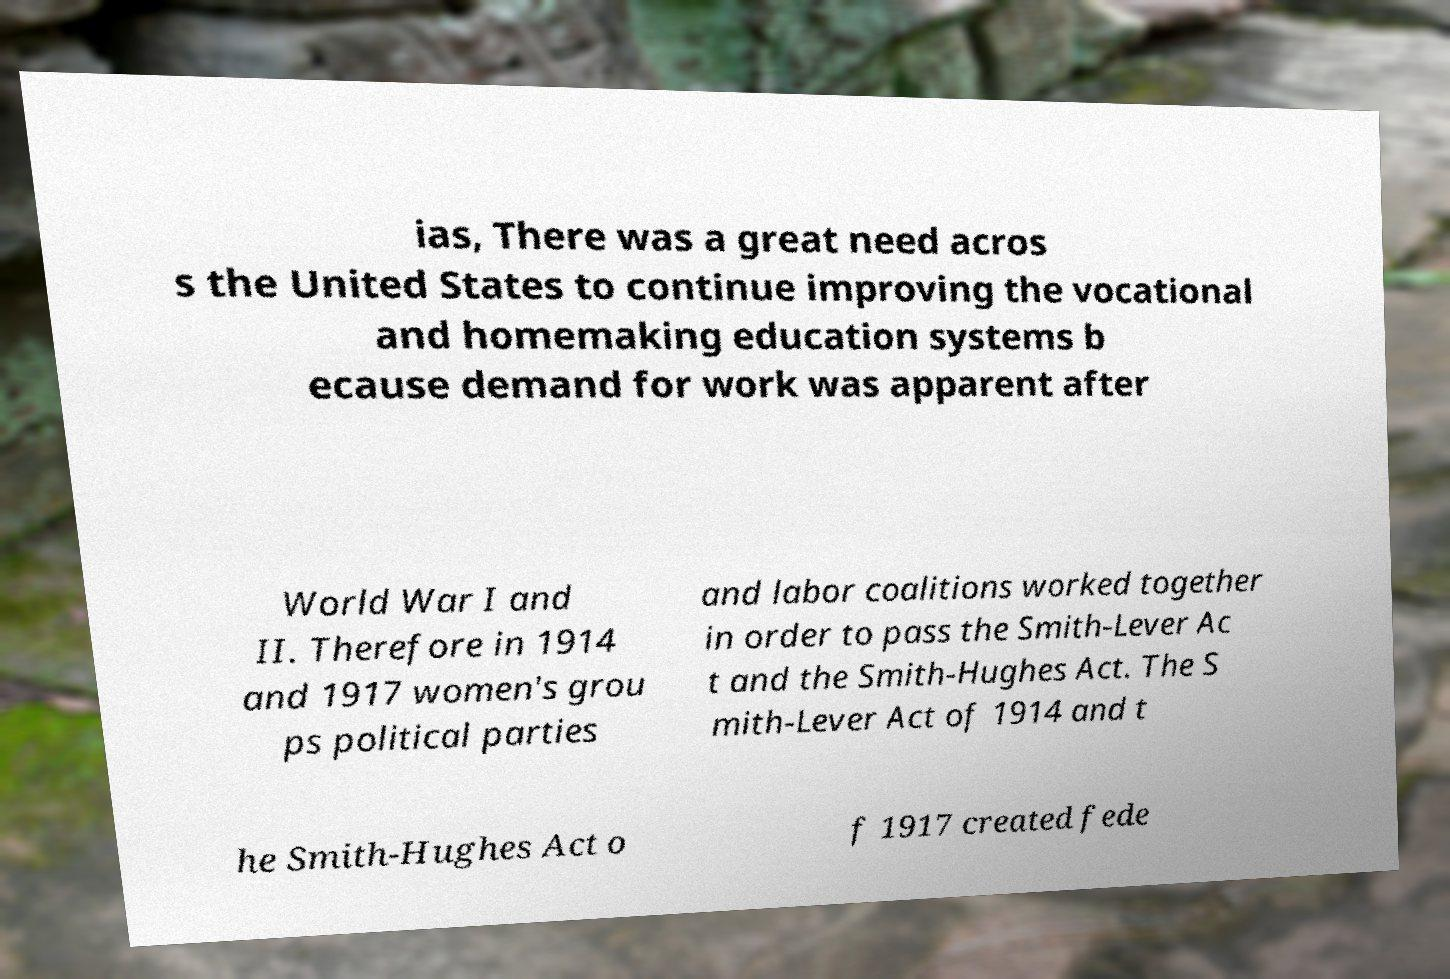What messages or text are displayed in this image? I need them in a readable, typed format. ias, There was a great need acros s the United States to continue improving the vocational and homemaking education systems b ecause demand for work was apparent after World War I and II. Therefore in 1914 and 1917 women's grou ps political parties and labor coalitions worked together in order to pass the Smith-Lever Ac t and the Smith-Hughes Act. The S mith-Lever Act of 1914 and t he Smith-Hughes Act o f 1917 created fede 